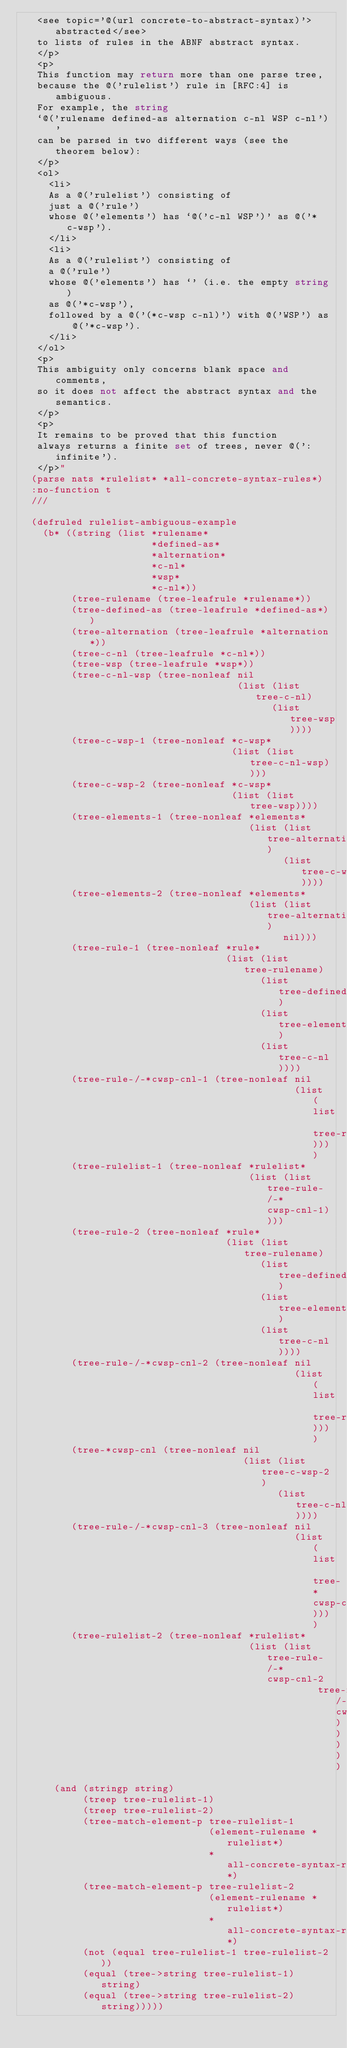Convert code to text. <code><loc_0><loc_0><loc_500><loc_500><_Lisp_>   <see topic='@(url concrete-to-abstract-syntax)'>abstracted</see>
   to lists of rules in the ABNF abstract syntax.
   </p>
   <p>
   This function may return more than one parse tree,
   because the @('rulelist') rule in [RFC:4] is ambiguous.
   For example, the string
   `@('rulename defined-as alternation c-nl WSP c-nl')'
   can be parsed in two different ways (see the theorem below):
   </p>
   <ol>
     <li>
     As a @('rulelist') consisting of
     just a @('rule')
     whose @('elements') has `@('c-nl WSP')' as @('*c-wsp').
     </li>
     <li>
     As a @('rulelist') consisting of
     a @('rule')
     whose @('elements') has `' (i.e. the empty string)
     as @('*c-wsp'),
     followed by a @('(*c-wsp c-nl)') with @('WSP') as @('*c-wsp').
     </li>
   </ol>
   <p>
   This ambiguity only concerns blank space and comments,
   so it does not affect the abstract syntax and the semantics.
   </p>
   <p>
   It remains to be proved that this function
   always returns a finite set of trees, never @(':infinite').
   </p>"
  (parse nats *rulelist* *all-concrete-syntax-rules*)
  :no-function t
  ///

  (defruled rulelist-ambiguous-example
    (b* ((string (list *rulename*
                       *defined-as*
                       *alternation*
                       *c-nl*
                       *wsp*
                       *c-nl*))
         (tree-rulename (tree-leafrule *rulename*))
         (tree-defined-as (tree-leafrule *defined-as*))
         (tree-alternation (tree-leafrule *alternation*))
         (tree-c-nl (tree-leafrule *c-nl*))
         (tree-wsp (tree-leafrule *wsp*))
         (tree-c-nl-wsp (tree-nonleaf nil
                                      (list (list tree-c-nl)
                                            (list tree-wsp))))
         (tree-c-wsp-1 (tree-nonleaf *c-wsp*
                                     (list (list tree-c-nl-wsp))))
         (tree-c-wsp-2 (tree-nonleaf *c-wsp*
                                     (list (list tree-wsp))))
         (tree-elements-1 (tree-nonleaf *elements*
                                        (list (list tree-alternation)
                                              (list tree-c-wsp-1))))
         (tree-elements-2 (tree-nonleaf *elements*
                                        (list (list tree-alternation)
                                              nil)))
         (tree-rule-1 (tree-nonleaf *rule*
                                    (list (list tree-rulename)
                                          (list tree-defined-as)
                                          (list tree-elements-1)
                                          (list tree-c-nl))))
         (tree-rule-/-*cwsp-cnl-1 (tree-nonleaf nil
                                                (list (list tree-rule-1))))
         (tree-rulelist-1 (tree-nonleaf *rulelist*
                                        (list (list tree-rule-/-*cwsp-cnl-1))))
         (tree-rule-2 (tree-nonleaf *rule*
                                    (list (list tree-rulename)
                                          (list tree-defined-as)
                                          (list tree-elements-2)
                                          (list tree-c-nl))))
         (tree-rule-/-*cwsp-cnl-2 (tree-nonleaf nil
                                                (list (list tree-rule-2))))
         (tree-*cwsp-cnl (tree-nonleaf nil
                                       (list (list tree-c-wsp-2)
                                             (list tree-c-nl))))
         (tree-rule-/-*cwsp-cnl-3 (tree-nonleaf nil
                                                (list (list tree-*cwsp-cnl))))
         (tree-rulelist-2 (tree-nonleaf *rulelist*
                                        (list (list tree-rule-/-*cwsp-cnl-2
                                                    tree-rule-/-*cwsp-cnl-3)))))
      (and (stringp string)
           (treep tree-rulelist-1)
           (treep tree-rulelist-2)
           (tree-match-element-p tree-rulelist-1
                                 (element-rulename *rulelist*)
                                 *all-concrete-syntax-rules*)
           (tree-match-element-p tree-rulelist-2
                                 (element-rulename *rulelist*)
                                 *all-concrete-syntax-rules*)
           (not (equal tree-rulelist-1 tree-rulelist-2))
           (equal (tree->string tree-rulelist-1) string)
           (equal (tree->string tree-rulelist-2) string)))))
</code> 